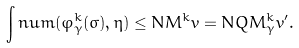Convert formula to latex. <formula><loc_0><loc_0><loc_500><loc_500>\int n u m ( \varphi _ { \gamma } ^ { k } ( \sigma ) , \eta ) \leq N M ^ { k } v = N Q M _ { \gamma } ^ { k } v ^ { \prime } .</formula> 